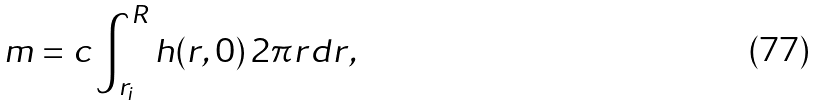Convert formula to latex. <formula><loc_0><loc_0><loc_500><loc_500>m = c \int _ { r _ { i } } ^ { R } h ( r , 0 ) \, 2 \pi r d r ,</formula> 